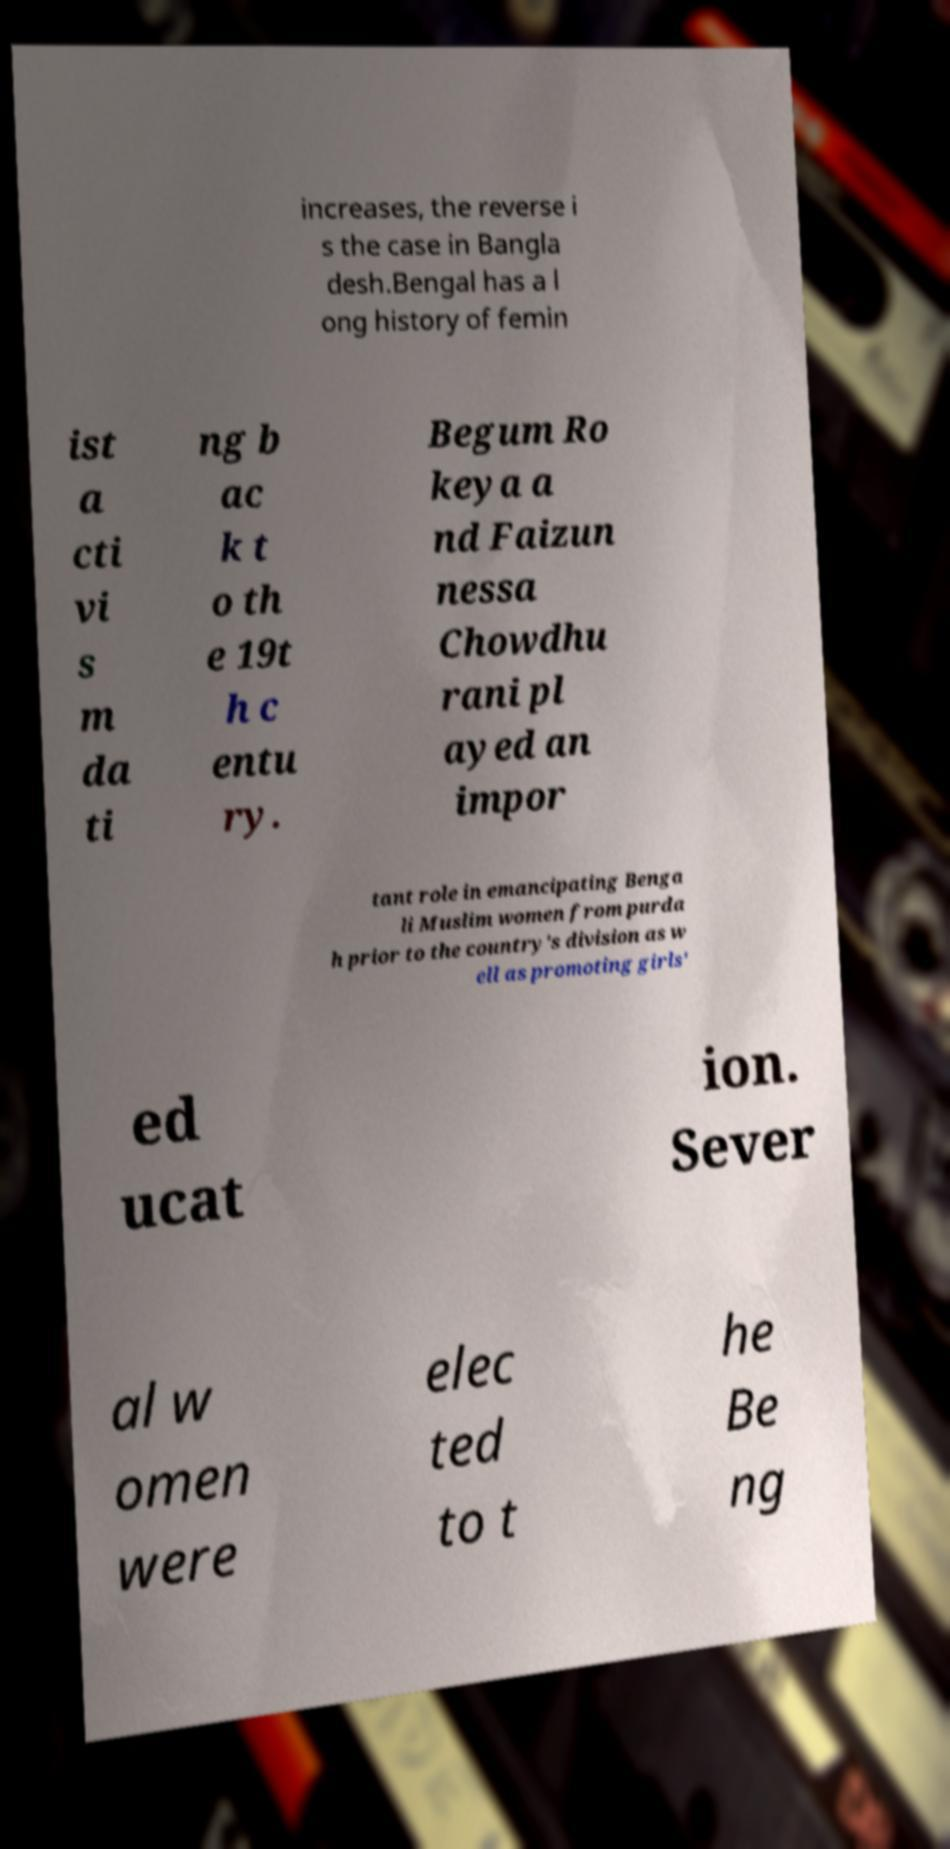Can you read and provide the text displayed in the image?This photo seems to have some interesting text. Can you extract and type it out for me? increases, the reverse i s the case in Bangla desh.Bengal has a l ong history of femin ist a cti vi s m da ti ng b ac k t o th e 19t h c entu ry. Begum Ro keya a nd Faizun nessa Chowdhu rani pl ayed an impor tant role in emancipating Benga li Muslim women from purda h prior to the country's division as w ell as promoting girls' ed ucat ion. Sever al w omen were elec ted to t he Be ng 